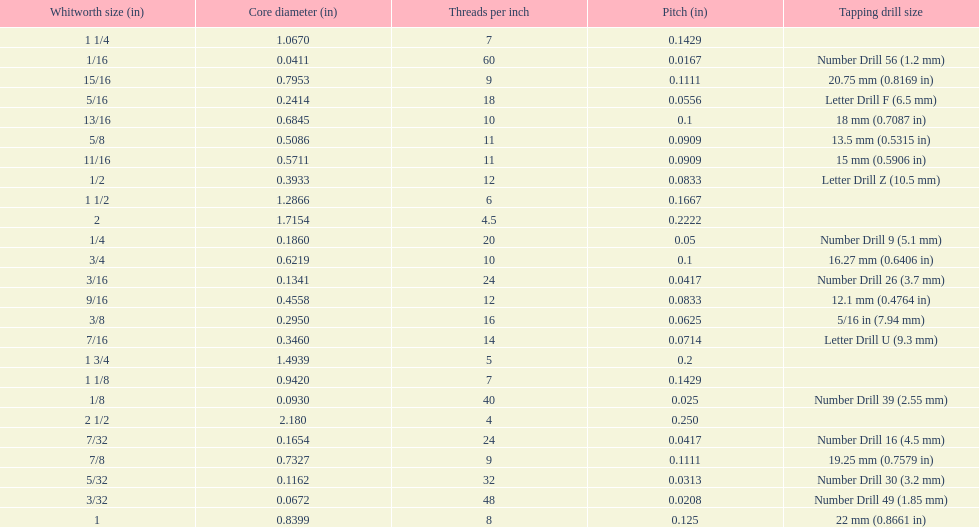What is the core diameter of the last whitworth thread size? 2.180. 